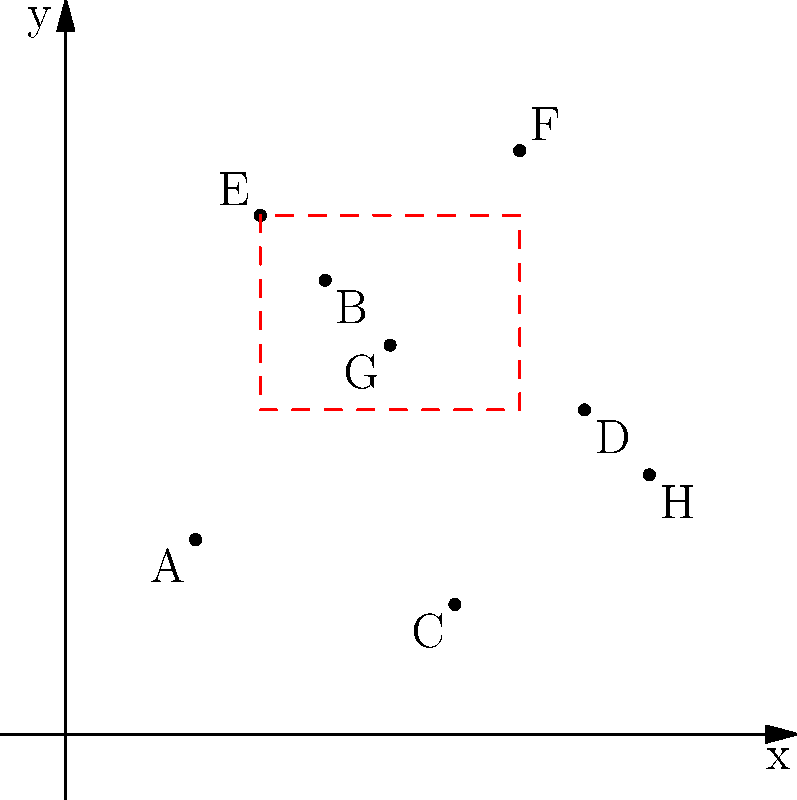As a small business owner with a limited marketing budget, you've plotted the locations of your most valuable customers on a coordinate plane to identify target areas for focused marketing efforts. The graph shows 8 customer locations labeled A through H. You want to focus on a rectangular area that encompasses the highest concentration of customers. Which customers are included in the target area represented by the red dashed rectangle, and what are the coordinates of this rectangle's corners? To answer this question, we need to analyze the graph and follow these steps:

1. Identify the customers within the red dashed rectangle:
   - Customer B (4,7)
   - Customer E (3,8)
   - Customer F (7,9)
   - Customer G (5,6)

2. Determine the coordinates of the rectangle's corners:
   - Bottom-left corner: (3,5)
   - Top-left corner: (3,8)
   - Bottom-right corner: (7,5)
   - Top-right corner: (7,8)

3. Express the rectangle's coordinates as ordered pairs:
   $$(3,5), (3,8), (7,5), (7,8)$$

4. List the customers included in the target area:
   B, E, F, and G

By focusing on this area, you can concentrate your limited marketing budget on the region with the highest density of valuable customers, potentially increasing the effectiveness of your marketing efforts.
Answer: Customers B, E, F, G; Rectangle corners: (3,5), (3,8), (7,5), (7,8) 